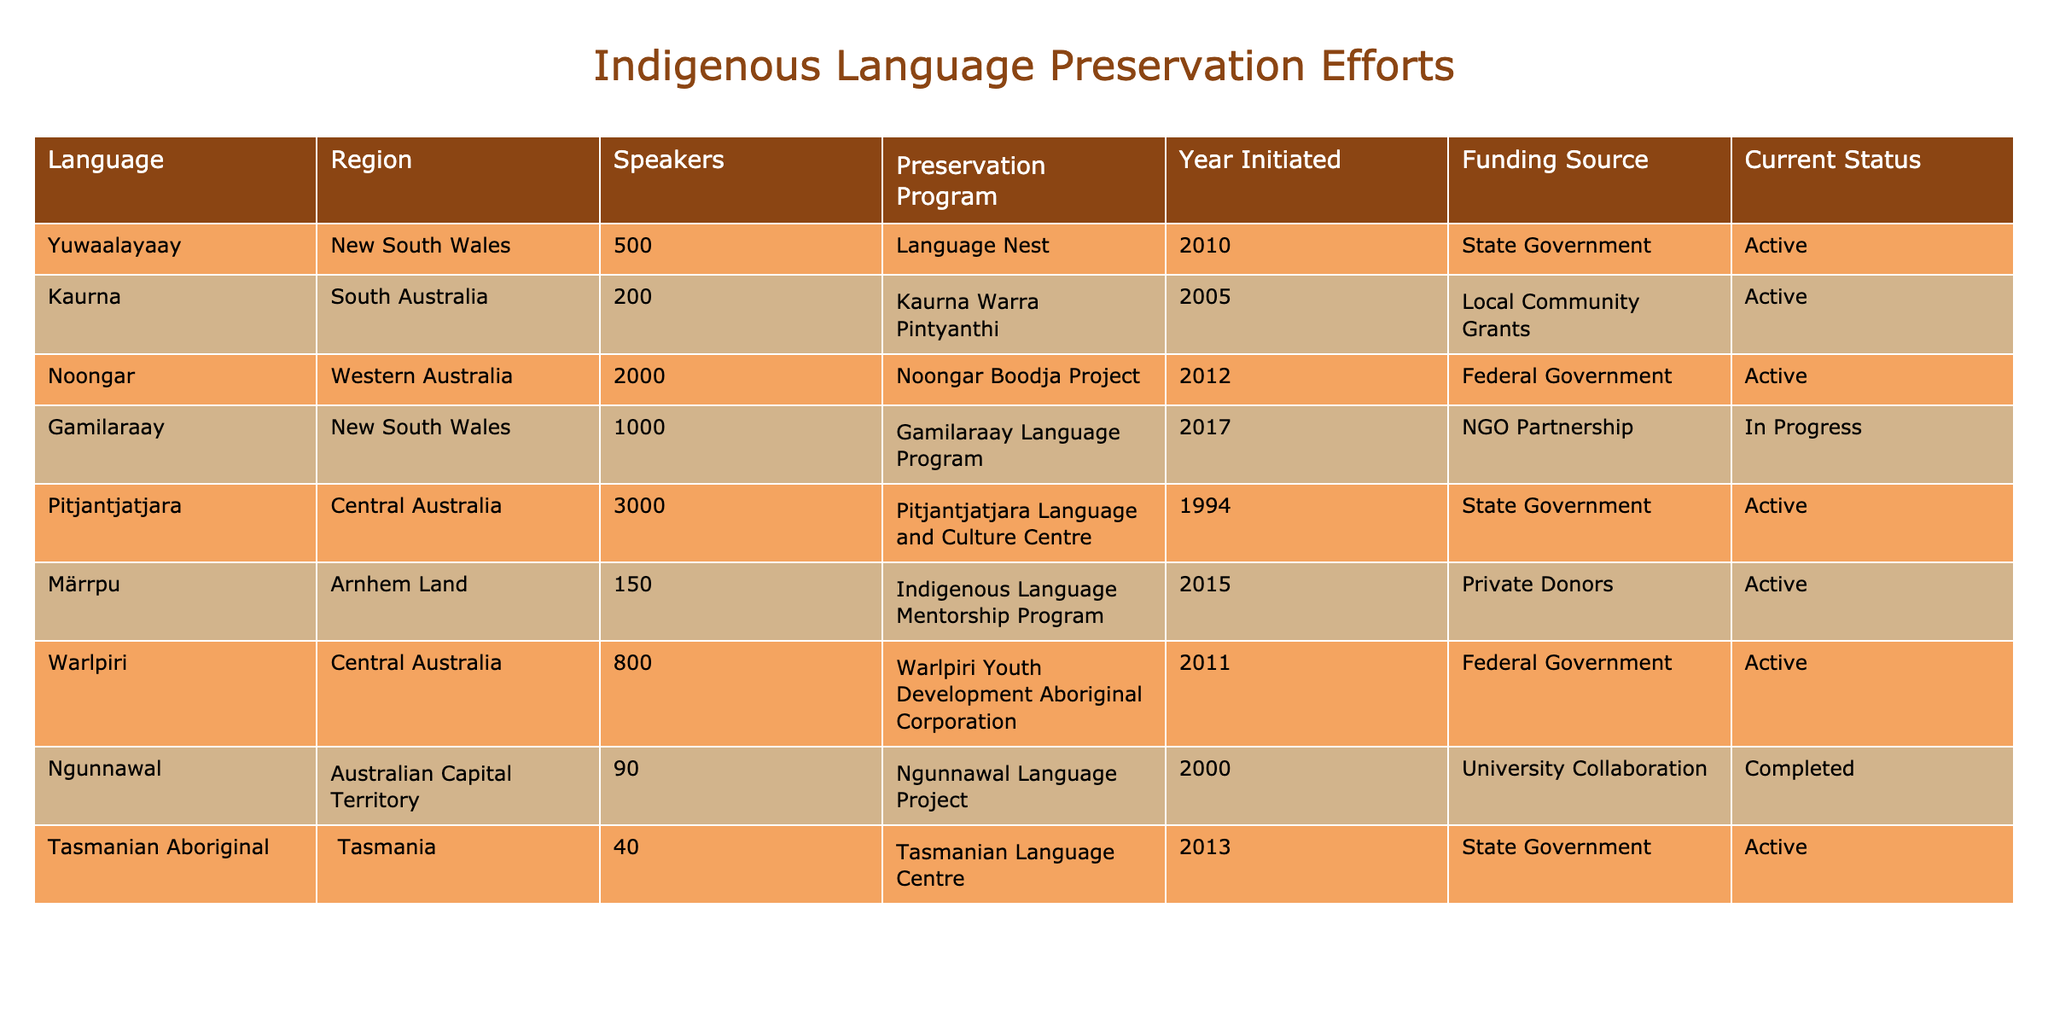What is the current status of the Kaurna language preservation efforts? The table lists the Kaurna language preservation program under the "Current Status" column, which shows that it is "Active."
Answer: Active How many speakers does the Yuwaalayaay language have? By looking in the "Speakers" column adjacent to the Yuwaalayaay language entry, it shows there are 500 speakers.
Answer: 500 What year was the Noongar Boodja Project initiated? The year is presented in the "Year Initiated" column next to the Noongar entry, which indicates it was initiated in 2012.
Answer: 2012 Which preservation program has the highest number of speakers? By comparing the values in the "Speakers" column, Pitjantjatjara has the highest value at 3000 speakers.
Answer: Pitjantjatjara Language and Culture Centre Is the Ngunnawal Language Project still active? The table indicates the "Current Status" of the Ngunnawal Language Project is listed as "Completed," meaning it is not active anymore.
Answer: No What is the total number of speakers for languages in New South Wales? The languages in New South Wales listed are Yuwaalayaay with 500 speakers and Gamilaraay with 1000 speakers. Summing these gives 500 + 1000 = 1500 speakers total for New South Wales.
Answer: 1500 Which language preservation efforts were funded by the Federal Government? The table shows two languages—Noongar Boodja Project and Warlpiri Youth Development Aboriginal Corporation—under the "Funding Source" column where the source is Federal Government.
Answer: Noongar Boodja Project, Warlpiri Youth Development Aboriginal Corporation What percentage of the total speakers represented by the table belongs to the Kaurna language? Adding all speakers gives a total of 500 + 200 + 2000 + 1000 + 3000 + 150 + 800 + 90 + 40 = 6400 speakers total. The Kaurna language has 200 speakers, so (200/6400) * 100 = 3.125%.
Answer: 3.125% How many preservation programs were initiated after 2010? By examining the "Year Initiated" column, the programs initiated after 2010 are Gamilaraay Language Program (2017), Noongar Boodja Project (2012), and Warlpiri Youth Development Aboriginal Corporation (2011). This totals to three programs.
Answer: 3 